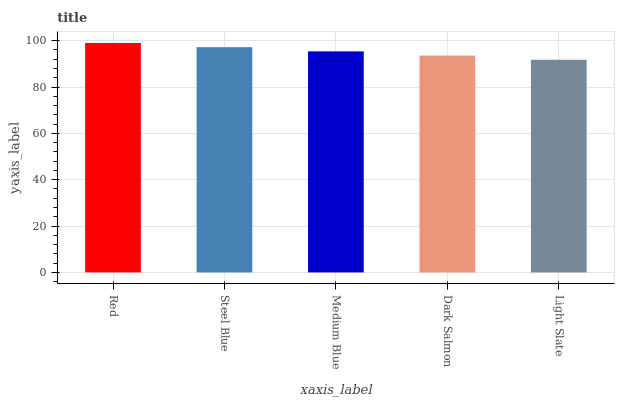Is Light Slate the minimum?
Answer yes or no. Yes. Is Red the maximum?
Answer yes or no. Yes. Is Steel Blue the minimum?
Answer yes or no. No. Is Steel Blue the maximum?
Answer yes or no. No. Is Red greater than Steel Blue?
Answer yes or no. Yes. Is Steel Blue less than Red?
Answer yes or no. Yes. Is Steel Blue greater than Red?
Answer yes or no. No. Is Red less than Steel Blue?
Answer yes or no. No. Is Medium Blue the high median?
Answer yes or no. Yes. Is Medium Blue the low median?
Answer yes or no. Yes. Is Dark Salmon the high median?
Answer yes or no. No. Is Steel Blue the low median?
Answer yes or no. No. 